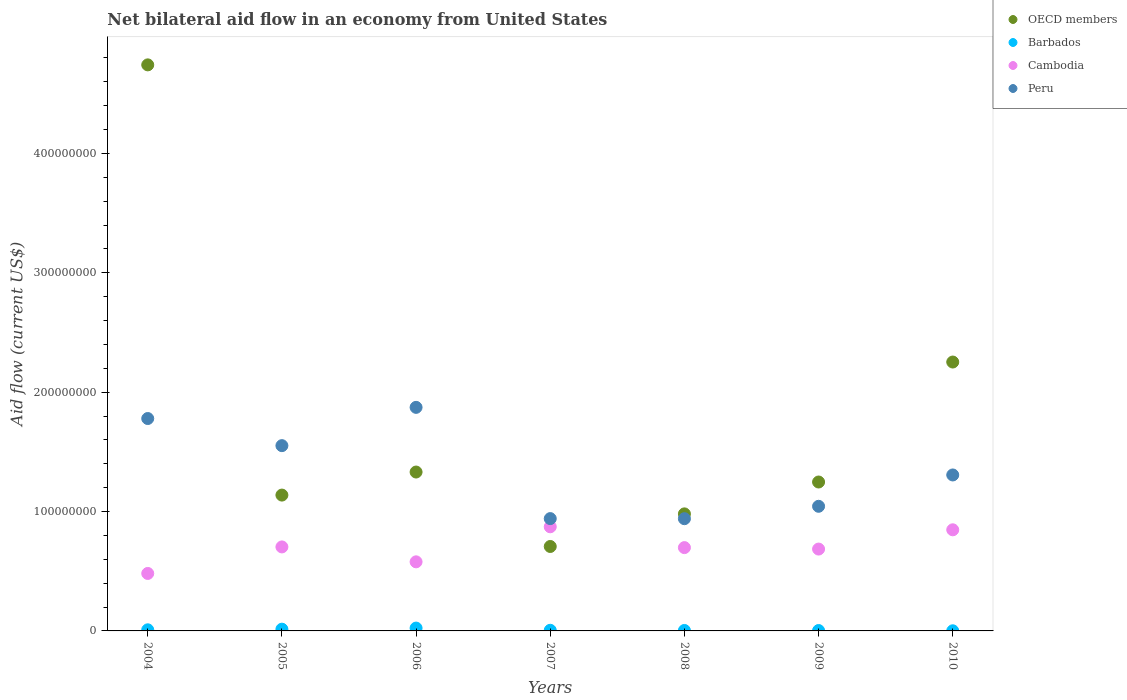What is the net bilateral aid flow in Peru in 2008?
Offer a very short reply. 9.40e+07. Across all years, what is the maximum net bilateral aid flow in OECD members?
Your answer should be compact. 4.74e+08. Across all years, what is the minimum net bilateral aid flow in Cambodia?
Give a very brief answer. 4.81e+07. What is the total net bilateral aid flow in Barbados in the graph?
Give a very brief answer. 6.13e+06. What is the difference between the net bilateral aid flow in OECD members in 2006 and that in 2007?
Keep it short and to the point. 6.24e+07. What is the difference between the net bilateral aid flow in Cambodia in 2006 and the net bilateral aid flow in OECD members in 2007?
Give a very brief answer. -1.29e+07. What is the average net bilateral aid flow in Peru per year?
Provide a short and direct response. 1.35e+08. In the year 2009, what is the difference between the net bilateral aid flow in Barbados and net bilateral aid flow in OECD members?
Give a very brief answer. -1.24e+08. What is the ratio of the net bilateral aid flow in Peru in 2007 to that in 2009?
Keep it short and to the point. 0.9. What is the difference between the highest and the second highest net bilateral aid flow in OECD members?
Offer a terse response. 2.49e+08. What is the difference between the highest and the lowest net bilateral aid flow in OECD members?
Keep it short and to the point. 4.03e+08. In how many years, is the net bilateral aid flow in Peru greater than the average net bilateral aid flow in Peru taken over all years?
Your response must be concise. 3. Is the net bilateral aid flow in Cambodia strictly greater than the net bilateral aid flow in Barbados over the years?
Your answer should be compact. Yes. How many dotlines are there?
Your answer should be compact. 4. What is the difference between two consecutive major ticks on the Y-axis?
Your response must be concise. 1.00e+08. Are the values on the major ticks of Y-axis written in scientific E-notation?
Offer a terse response. No. Does the graph contain any zero values?
Your answer should be very brief. No. Where does the legend appear in the graph?
Your answer should be compact. Top right. What is the title of the graph?
Make the answer very short. Net bilateral aid flow in an economy from United States. Does "Kenya" appear as one of the legend labels in the graph?
Ensure brevity in your answer.  No. What is the label or title of the X-axis?
Offer a terse response. Years. What is the Aid flow (current US$) in OECD members in 2004?
Provide a succinct answer. 4.74e+08. What is the Aid flow (current US$) in Barbados in 2004?
Ensure brevity in your answer.  9.30e+05. What is the Aid flow (current US$) of Cambodia in 2004?
Give a very brief answer. 4.81e+07. What is the Aid flow (current US$) in Peru in 2004?
Give a very brief answer. 1.78e+08. What is the Aid flow (current US$) in OECD members in 2005?
Your answer should be very brief. 1.14e+08. What is the Aid flow (current US$) in Barbados in 2005?
Your answer should be very brief. 1.46e+06. What is the Aid flow (current US$) of Cambodia in 2005?
Offer a very short reply. 7.04e+07. What is the Aid flow (current US$) of Peru in 2005?
Ensure brevity in your answer.  1.55e+08. What is the Aid flow (current US$) in OECD members in 2006?
Offer a terse response. 1.33e+08. What is the Aid flow (current US$) in Barbados in 2006?
Offer a very short reply. 2.38e+06. What is the Aid flow (current US$) of Cambodia in 2006?
Give a very brief answer. 5.79e+07. What is the Aid flow (current US$) in Peru in 2006?
Make the answer very short. 1.87e+08. What is the Aid flow (current US$) in OECD members in 2007?
Ensure brevity in your answer.  7.07e+07. What is the Aid flow (current US$) in Barbados in 2007?
Provide a short and direct response. 5.30e+05. What is the Aid flow (current US$) of Cambodia in 2007?
Offer a very short reply. 8.72e+07. What is the Aid flow (current US$) in Peru in 2007?
Keep it short and to the point. 9.41e+07. What is the Aid flow (current US$) in OECD members in 2008?
Your answer should be compact. 9.80e+07. What is the Aid flow (current US$) in Cambodia in 2008?
Provide a succinct answer. 6.98e+07. What is the Aid flow (current US$) of Peru in 2008?
Keep it short and to the point. 9.40e+07. What is the Aid flow (current US$) in OECD members in 2009?
Make the answer very short. 1.25e+08. What is the Aid flow (current US$) of Cambodia in 2009?
Your answer should be very brief. 6.86e+07. What is the Aid flow (current US$) in Peru in 2009?
Your answer should be compact. 1.04e+08. What is the Aid flow (current US$) in OECD members in 2010?
Provide a short and direct response. 2.25e+08. What is the Aid flow (current US$) in Barbados in 2010?
Provide a succinct answer. 1.10e+05. What is the Aid flow (current US$) of Cambodia in 2010?
Your answer should be compact. 8.47e+07. What is the Aid flow (current US$) of Peru in 2010?
Your answer should be very brief. 1.31e+08. Across all years, what is the maximum Aid flow (current US$) in OECD members?
Your response must be concise. 4.74e+08. Across all years, what is the maximum Aid flow (current US$) in Barbados?
Keep it short and to the point. 2.38e+06. Across all years, what is the maximum Aid flow (current US$) in Cambodia?
Offer a very short reply. 8.72e+07. Across all years, what is the maximum Aid flow (current US$) in Peru?
Your answer should be very brief. 1.87e+08. Across all years, what is the minimum Aid flow (current US$) in OECD members?
Your response must be concise. 7.07e+07. Across all years, what is the minimum Aid flow (current US$) of Cambodia?
Your answer should be very brief. 4.81e+07. Across all years, what is the minimum Aid flow (current US$) in Peru?
Give a very brief answer. 9.40e+07. What is the total Aid flow (current US$) of OECD members in the graph?
Your answer should be very brief. 1.24e+09. What is the total Aid flow (current US$) in Barbados in the graph?
Provide a short and direct response. 6.13e+06. What is the total Aid flow (current US$) in Cambodia in the graph?
Your answer should be compact. 4.87e+08. What is the total Aid flow (current US$) of Peru in the graph?
Provide a succinct answer. 9.43e+08. What is the difference between the Aid flow (current US$) of OECD members in 2004 and that in 2005?
Provide a succinct answer. 3.60e+08. What is the difference between the Aid flow (current US$) in Barbados in 2004 and that in 2005?
Give a very brief answer. -5.30e+05. What is the difference between the Aid flow (current US$) in Cambodia in 2004 and that in 2005?
Provide a short and direct response. -2.22e+07. What is the difference between the Aid flow (current US$) of Peru in 2004 and that in 2005?
Your response must be concise. 2.27e+07. What is the difference between the Aid flow (current US$) of OECD members in 2004 and that in 2006?
Offer a very short reply. 3.41e+08. What is the difference between the Aid flow (current US$) in Barbados in 2004 and that in 2006?
Your answer should be compact. -1.45e+06. What is the difference between the Aid flow (current US$) in Cambodia in 2004 and that in 2006?
Your answer should be compact. -9.73e+06. What is the difference between the Aid flow (current US$) of Peru in 2004 and that in 2006?
Your answer should be compact. -9.35e+06. What is the difference between the Aid flow (current US$) of OECD members in 2004 and that in 2007?
Your answer should be compact. 4.03e+08. What is the difference between the Aid flow (current US$) in Barbados in 2004 and that in 2007?
Your answer should be compact. 4.00e+05. What is the difference between the Aid flow (current US$) in Cambodia in 2004 and that in 2007?
Ensure brevity in your answer.  -3.91e+07. What is the difference between the Aid flow (current US$) in Peru in 2004 and that in 2007?
Offer a terse response. 8.38e+07. What is the difference between the Aid flow (current US$) of OECD members in 2004 and that in 2008?
Offer a terse response. 3.76e+08. What is the difference between the Aid flow (current US$) in Barbados in 2004 and that in 2008?
Make the answer very short. 5.40e+05. What is the difference between the Aid flow (current US$) of Cambodia in 2004 and that in 2008?
Your answer should be very brief. -2.16e+07. What is the difference between the Aid flow (current US$) of Peru in 2004 and that in 2008?
Provide a short and direct response. 8.39e+07. What is the difference between the Aid flow (current US$) in OECD members in 2004 and that in 2009?
Keep it short and to the point. 3.49e+08. What is the difference between the Aid flow (current US$) in Cambodia in 2004 and that in 2009?
Keep it short and to the point. -2.04e+07. What is the difference between the Aid flow (current US$) in Peru in 2004 and that in 2009?
Your response must be concise. 7.35e+07. What is the difference between the Aid flow (current US$) in OECD members in 2004 and that in 2010?
Give a very brief answer. 2.49e+08. What is the difference between the Aid flow (current US$) in Barbados in 2004 and that in 2010?
Offer a very short reply. 8.20e+05. What is the difference between the Aid flow (current US$) in Cambodia in 2004 and that in 2010?
Make the answer very short. -3.66e+07. What is the difference between the Aid flow (current US$) in Peru in 2004 and that in 2010?
Offer a terse response. 4.73e+07. What is the difference between the Aid flow (current US$) in OECD members in 2005 and that in 2006?
Your response must be concise. -1.93e+07. What is the difference between the Aid flow (current US$) of Barbados in 2005 and that in 2006?
Your answer should be compact. -9.20e+05. What is the difference between the Aid flow (current US$) of Cambodia in 2005 and that in 2006?
Give a very brief answer. 1.25e+07. What is the difference between the Aid flow (current US$) of Peru in 2005 and that in 2006?
Ensure brevity in your answer.  -3.21e+07. What is the difference between the Aid flow (current US$) in OECD members in 2005 and that in 2007?
Ensure brevity in your answer.  4.30e+07. What is the difference between the Aid flow (current US$) in Barbados in 2005 and that in 2007?
Offer a terse response. 9.30e+05. What is the difference between the Aid flow (current US$) of Cambodia in 2005 and that in 2007?
Your answer should be very brief. -1.69e+07. What is the difference between the Aid flow (current US$) of Peru in 2005 and that in 2007?
Provide a short and direct response. 6.11e+07. What is the difference between the Aid flow (current US$) in OECD members in 2005 and that in 2008?
Ensure brevity in your answer.  1.57e+07. What is the difference between the Aid flow (current US$) of Barbados in 2005 and that in 2008?
Your response must be concise. 1.07e+06. What is the difference between the Aid flow (current US$) of Cambodia in 2005 and that in 2008?
Your answer should be very brief. 5.80e+05. What is the difference between the Aid flow (current US$) in Peru in 2005 and that in 2008?
Keep it short and to the point. 6.12e+07. What is the difference between the Aid flow (current US$) of OECD members in 2005 and that in 2009?
Ensure brevity in your answer.  -1.10e+07. What is the difference between the Aid flow (current US$) in Barbados in 2005 and that in 2009?
Ensure brevity in your answer.  1.13e+06. What is the difference between the Aid flow (current US$) of Cambodia in 2005 and that in 2009?
Offer a terse response. 1.80e+06. What is the difference between the Aid flow (current US$) in Peru in 2005 and that in 2009?
Ensure brevity in your answer.  5.08e+07. What is the difference between the Aid flow (current US$) of OECD members in 2005 and that in 2010?
Make the answer very short. -1.11e+08. What is the difference between the Aid flow (current US$) in Barbados in 2005 and that in 2010?
Ensure brevity in your answer.  1.35e+06. What is the difference between the Aid flow (current US$) in Cambodia in 2005 and that in 2010?
Your answer should be very brief. -1.43e+07. What is the difference between the Aid flow (current US$) in Peru in 2005 and that in 2010?
Provide a short and direct response. 2.46e+07. What is the difference between the Aid flow (current US$) in OECD members in 2006 and that in 2007?
Provide a short and direct response. 6.24e+07. What is the difference between the Aid flow (current US$) in Barbados in 2006 and that in 2007?
Provide a short and direct response. 1.85e+06. What is the difference between the Aid flow (current US$) of Cambodia in 2006 and that in 2007?
Offer a very short reply. -2.94e+07. What is the difference between the Aid flow (current US$) of Peru in 2006 and that in 2007?
Keep it short and to the point. 9.32e+07. What is the difference between the Aid flow (current US$) of OECD members in 2006 and that in 2008?
Make the answer very short. 3.50e+07. What is the difference between the Aid flow (current US$) of Barbados in 2006 and that in 2008?
Make the answer very short. 1.99e+06. What is the difference between the Aid flow (current US$) of Cambodia in 2006 and that in 2008?
Make the answer very short. -1.19e+07. What is the difference between the Aid flow (current US$) of Peru in 2006 and that in 2008?
Make the answer very short. 9.33e+07. What is the difference between the Aid flow (current US$) in OECD members in 2006 and that in 2009?
Offer a terse response. 8.36e+06. What is the difference between the Aid flow (current US$) in Barbados in 2006 and that in 2009?
Keep it short and to the point. 2.05e+06. What is the difference between the Aid flow (current US$) of Cambodia in 2006 and that in 2009?
Give a very brief answer. -1.07e+07. What is the difference between the Aid flow (current US$) of Peru in 2006 and that in 2009?
Make the answer very short. 8.29e+07. What is the difference between the Aid flow (current US$) in OECD members in 2006 and that in 2010?
Give a very brief answer. -9.21e+07. What is the difference between the Aid flow (current US$) of Barbados in 2006 and that in 2010?
Offer a very short reply. 2.27e+06. What is the difference between the Aid flow (current US$) of Cambodia in 2006 and that in 2010?
Give a very brief answer. -2.68e+07. What is the difference between the Aid flow (current US$) of Peru in 2006 and that in 2010?
Your answer should be compact. 5.66e+07. What is the difference between the Aid flow (current US$) of OECD members in 2007 and that in 2008?
Provide a succinct answer. -2.73e+07. What is the difference between the Aid flow (current US$) in Cambodia in 2007 and that in 2008?
Your answer should be compact. 1.74e+07. What is the difference between the Aid flow (current US$) of Peru in 2007 and that in 2008?
Provide a succinct answer. 8.00e+04. What is the difference between the Aid flow (current US$) of OECD members in 2007 and that in 2009?
Provide a succinct answer. -5.40e+07. What is the difference between the Aid flow (current US$) in Barbados in 2007 and that in 2009?
Offer a very short reply. 2.00e+05. What is the difference between the Aid flow (current US$) of Cambodia in 2007 and that in 2009?
Offer a terse response. 1.87e+07. What is the difference between the Aid flow (current US$) in Peru in 2007 and that in 2009?
Your answer should be compact. -1.03e+07. What is the difference between the Aid flow (current US$) of OECD members in 2007 and that in 2010?
Your answer should be very brief. -1.54e+08. What is the difference between the Aid flow (current US$) in Cambodia in 2007 and that in 2010?
Your answer should be compact. 2.52e+06. What is the difference between the Aid flow (current US$) in Peru in 2007 and that in 2010?
Your response must be concise. -3.66e+07. What is the difference between the Aid flow (current US$) of OECD members in 2008 and that in 2009?
Your response must be concise. -2.67e+07. What is the difference between the Aid flow (current US$) in Barbados in 2008 and that in 2009?
Give a very brief answer. 6.00e+04. What is the difference between the Aid flow (current US$) of Cambodia in 2008 and that in 2009?
Your response must be concise. 1.22e+06. What is the difference between the Aid flow (current US$) in Peru in 2008 and that in 2009?
Make the answer very short. -1.04e+07. What is the difference between the Aid flow (current US$) of OECD members in 2008 and that in 2010?
Ensure brevity in your answer.  -1.27e+08. What is the difference between the Aid flow (current US$) in Barbados in 2008 and that in 2010?
Ensure brevity in your answer.  2.80e+05. What is the difference between the Aid flow (current US$) in Cambodia in 2008 and that in 2010?
Your response must be concise. -1.49e+07. What is the difference between the Aid flow (current US$) in Peru in 2008 and that in 2010?
Give a very brief answer. -3.66e+07. What is the difference between the Aid flow (current US$) of OECD members in 2009 and that in 2010?
Make the answer very short. -1.00e+08. What is the difference between the Aid flow (current US$) of Barbados in 2009 and that in 2010?
Make the answer very short. 2.20e+05. What is the difference between the Aid flow (current US$) of Cambodia in 2009 and that in 2010?
Provide a succinct answer. -1.61e+07. What is the difference between the Aid flow (current US$) in Peru in 2009 and that in 2010?
Provide a succinct answer. -2.62e+07. What is the difference between the Aid flow (current US$) of OECD members in 2004 and the Aid flow (current US$) of Barbados in 2005?
Your response must be concise. 4.73e+08. What is the difference between the Aid flow (current US$) in OECD members in 2004 and the Aid flow (current US$) in Cambodia in 2005?
Give a very brief answer. 4.04e+08. What is the difference between the Aid flow (current US$) of OECD members in 2004 and the Aid flow (current US$) of Peru in 2005?
Give a very brief answer. 3.19e+08. What is the difference between the Aid flow (current US$) of Barbados in 2004 and the Aid flow (current US$) of Cambodia in 2005?
Make the answer very short. -6.94e+07. What is the difference between the Aid flow (current US$) of Barbados in 2004 and the Aid flow (current US$) of Peru in 2005?
Make the answer very short. -1.54e+08. What is the difference between the Aid flow (current US$) of Cambodia in 2004 and the Aid flow (current US$) of Peru in 2005?
Offer a very short reply. -1.07e+08. What is the difference between the Aid flow (current US$) in OECD members in 2004 and the Aid flow (current US$) in Barbados in 2006?
Offer a terse response. 4.72e+08. What is the difference between the Aid flow (current US$) in OECD members in 2004 and the Aid flow (current US$) in Cambodia in 2006?
Keep it short and to the point. 4.16e+08. What is the difference between the Aid flow (current US$) in OECD members in 2004 and the Aid flow (current US$) in Peru in 2006?
Provide a succinct answer. 2.87e+08. What is the difference between the Aid flow (current US$) in Barbados in 2004 and the Aid flow (current US$) in Cambodia in 2006?
Your response must be concise. -5.69e+07. What is the difference between the Aid flow (current US$) of Barbados in 2004 and the Aid flow (current US$) of Peru in 2006?
Your answer should be very brief. -1.86e+08. What is the difference between the Aid flow (current US$) of Cambodia in 2004 and the Aid flow (current US$) of Peru in 2006?
Offer a very short reply. -1.39e+08. What is the difference between the Aid flow (current US$) of OECD members in 2004 and the Aid flow (current US$) of Barbados in 2007?
Offer a terse response. 4.74e+08. What is the difference between the Aid flow (current US$) in OECD members in 2004 and the Aid flow (current US$) in Cambodia in 2007?
Offer a terse response. 3.87e+08. What is the difference between the Aid flow (current US$) in OECD members in 2004 and the Aid flow (current US$) in Peru in 2007?
Ensure brevity in your answer.  3.80e+08. What is the difference between the Aid flow (current US$) of Barbados in 2004 and the Aid flow (current US$) of Cambodia in 2007?
Your answer should be compact. -8.63e+07. What is the difference between the Aid flow (current US$) in Barbados in 2004 and the Aid flow (current US$) in Peru in 2007?
Offer a terse response. -9.32e+07. What is the difference between the Aid flow (current US$) of Cambodia in 2004 and the Aid flow (current US$) of Peru in 2007?
Give a very brief answer. -4.59e+07. What is the difference between the Aid flow (current US$) of OECD members in 2004 and the Aid flow (current US$) of Barbados in 2008?
Provide a short and direct response. 4.74e+08. What is the difference between the Aid flow (current US$) of OECD members in 2004 and the Aid flow (current US$) of Cambodia in 2008?
Provide a short and direct response. 4.04e+08. What is the difference between the Aid flow (current US$) of OECD members in 2004 and the Aid flow (current US$) of Peru in 2008?
Provide a succinct answer. 3.80e+08. What is the difference between the Aid flow (current US$) in Barbados in 2004 and the Aid flow (current US$) in Cambodia in 2008?
Keep it short and to the point. -6.88e+07. What is the difference between the Aid flow (current US$) in Barbados in 2004 and the Aid flow (current US$) in Peru in 2008?
Your answer should be compact. -9.31e+07. What is the difference between the Aid flow (current US$) in Cambodia in 2004 and the Aid flow (current US$) in Peru in 2008?
Your answer should be compact. -4.59e+07. What is the difference between the Aid flow (current US$) in OECD members in 2004 and the Aid flow (current US$) in Barbados in 2009?
Offer a terse response. 4.74e+08. What is the difference between the Aid flow (current US$) in OECD members in 2004 and the Aid flow (current US$) in Cambodia in 2009?
Provide a succinct answer. 4.06e+08. What is the difference between the Aid flow (current US$) in OECD members in 2004 and the Aid flow (current US$) in Peru in 2009?
Keep it short and to the point. 3.70e+08. What is the difference between the Aid flow (current US$) in Barbados in 2004 and the Aid flow (current US$) in Cambodia in 2009?
Keep it short and to the point. -6.76e+07. What is the difference between the Aid flow (current US$) in Barbados in 2004 and the Aid flow (current US$) in Peru in 2009?
Offer a terse response. -1.03e+08. What is the difference between the Aid flow (current US$) in Cambodia in 2004 and the Aid flow (current US$) in Peru in 2009?
Provide a succinct answer. -5.62e+07. What is the difference between the Aid flow (current US$) of OECD members in 2004 and the Aid flow (current US$) of Barbados in 2010?
Ensure brevity in your answer.  4.74e+08. What is the difference between the Aid flow (current US$) in OECD members in 2004 and the Aid flow (current US$) in Cambodia in 2010?
Give a very brief answer. 3.89e+08. What is the difference between the Aid flow (current US$) of OECD members in 2004 and the Aid flow (current US$) of Peru in 2010?
Provide a short and direct response. 3.44e+08. What is the difference between the Aid flow (current US$) of Barbados in 2004 and the Aid flow (current US$) of Cambodia in 2010?
Your response must be concise. -8.38e+07. What is the difference between the Aid flow (current US$) of Barbados in 2004 and the Aid flow (current US$) of Peru in 2010?
Give a very brief answer. -1.30e+08. What is the difference between the Aid flow (current US$) in Cambodia in 2004 and the Aid flow (current US$) in Peru in 2010?
Keep it short and to the point. -8.25e+07. What is the difference between the Aid flow (current US$) in OECD members in 2005 and the Aid flow (current US$) in Barbados in 2006?
Ensure brevity in your answer.  1.11e+08. What is the difference between the Aid flow (current US$) of OECD members in 2005 and the Aid flow (current US$) of Cambodia in 2006?
Offer a very short reply. 5.59e+07. What is the difference between the Aid flow (current US$) of OECD members in 2005 and the Aid flow (current US$) of Peru in 2006?
Give a very brief answer. -7.35e+07. What is the difference between the Aid flow (current US$) in Barbados in 2005 and the Aid flow (current US$) in Cambodia in 2006?
Provide a succinct answer. -5.64e+07. What is the difference between the Aid flow (current US$) in Barbados in 2005 and the Aid flow (current US$) in Peru in 2006?
Your answer should be very brief. -1.86e+08. What is the difference between the Aid flow (current US$) in Cambodia in 2005 and the Aid flow (current US$) in Peru in 2006?
Ensure brevity in your answer.  -1.17e+08. What is the difference between the Aid flow (current US$) of OECD members in 2005 and the Aid flow (current US$) of Barbados in 2007?
Your answer should be very brief. 1.13e+08. What is the difference between the Aid flow (current US$) of OECD members in 2005 and the Aid flow (current US$) of Cambodia in 2007?
Provide a succinct answer. 2.66e+07. What is the difference between the Aid flow (current US$) in OECD members in 2005 and the Aid flow (current US$) in Peru in 2007?
Your response must be concise. 1.97e+07. What is the difference between the Aid flow (current US$) of Barbados in 2005 and the Aid flow (current US$) of Cambodia in 2007?
Provide a succinct answer. -8.58e+07. What is the difference between the Aid flow (current US$) of Barbados in 2005 and the Aid flow (current US$) of Peru in 2007?
Your answer should be compact. -9.26e+07. What is the difference between the Aid flow (current US$) in Cambodia in 2005 and the Aid flow (current US$) in Peru in 2007?
Your response must be concise. -2.37e+07. What is the difference between the Aid flow (current US$) of OECD members in 2005 and the Aid flow (current US$) of Barbados in 2008?
Give a very brief answer. 1.13e+08. What is the difference between the Aid flow (current US$) in OECD members in 2005 and the Aid flow (current US$) in Cambodia in 2008?
Provide a succinct answer. 4.40e+07. What is the difference between the Aid flow (current US$) in OECD members in 2005 and the Aid flow (current US$) in Peru in 2008?
Offer a terse response. 1.98e+07. What is the difference between the Aid flow (current US$) in Barbados in 2005 and the Aid flow (current US$) in Cambodia in 2008?
Provide a short and direct response. -6.83e+07. What is the difference between the Aid flow (current US$) in Barbados in 2005 and the Aid flow (current US$) in Peru in 2008?
Your answer should be compact. -9.25e+07. What is the difference between the Aid flow (current US$) in Cambodia in 2005 and the Aid flow (current US$) in Peru in 2008?
Keep it short and to the point. -2.36e+07. What is the difference between the Aid flow (current US$) of OECD members in 2005 and the Aid flow (current US$) of Barbados in 2009?
Your response must be concise. 1.13e+08. What is the difference between the Aid flow (current US$) of OECD members in 2005 and the Aid flow (current US$) of Cambodia in 2009?
Ensure brevity in your answer.  4.52e+07. What is the difference between the Aid flow (current US$) in OECD members in 2005 and the Aid flow (current US$) in Peru in 2009?
Give a very brief answer. 9.39e+06. What is the difference between the Aid flow (current US$) in Barbados in 2005 and the Aid flow (current US$) in Cambodia in 2009?
Offer a terse response. -6.71e+07. What is the difference between the Aid flow (current US$) in Barbados in 2005 and the Aid flow (current US$) in Peru in 2009?
Your answer should be compact. -1.03e+08. What is the difference between the Aid flow (current US$) of Cambodia in 2005 and the Aid flow (current US$) of Peru in 2009?
Keep it short and to the point. -3.40e+07. What is the difference between the Aid flow (current US$) in OECD members in 2005 and the Aid flow (current US$) in Barbados in 2010?
Your response must be concise. 1.14e+08. What is the difference between the Aid flow (current US$) of OECD members in 2005 and the Aid flow (current US$) of Cambodia in 2010?
Provide a short and direct response. 2.91e+07. What is the difference between the Aid flow (current US$) in OECD members in 2005 and the Aid flow (current US$) in Peru in 2010?
Keep it short and to the point. -1.69e+07. What is the difference between the Aid flow (current US$) of Barbados in 2005 and the Aid flow (current US$) of Cambodia in 2010?
Make the answer very short. -8.32e+07. What is the difference between the Aid flow (current US$) in Barbados in 2005 and the Aid flow (current US$) in Peru in 2010?
Offer a terse response. -1.29e+08. What is the difference between the Aid flow (current US$) of Cambodia in 2005 and the Aid flow (current US$) of Peru in 2010?
Your answer should be very brief. -6.03e+07. What is the difference between the Aid flow (current US$) of OECD members in 2006 and the Aid flow (current US$) of Barbados in 2007?
Offer a very short reply. 1.33e+08. What is the difference between the Aid flow (current US$) in OECD members in 2006 and the Aid flow (current US$) in Cambodia in 2007?
Ensure brevity in your answer.  4.59e+07. What is the difference between the Aid flow (current US$) of OECD members in 2006 and the Aid flow (current US$) of Peru in 2007?
Your response must be concise. 3.90e+07. What is the difference between the Aid flow (current US$) in Barbados in 2006 and the Aid flow (current US$) in Cambodia in 2007?
Ensure brevity in your answer.  -8.48e+07. What is the difference between the Aid flow (current US$) of Barbados in 2006 and the Aid flow (current US$) of Peru in 2007?
Keep it short and to the point. -9.17e+07. What is the difference between the Aid flow (current US$) in Cambodia in 2006 and the Aid flow (current US$) in Peru in 2007?
Provide a short and direct response. -3.62e+07. What is the difference between the Aid flow (current US$) in OECD members in 2006 and the Aid flow (current US$) in Barbados in 2008?
Your answer should be very brief. 1.33e+08. What is the difference between the Aid flow (current US$) of OECD members in 2006 and the Aid flow (current US$) of Cambodia in 2008?
Offer a terse response. 6.33e+07. What is the difference between the Aid flow (current US$) of OECD members in 2006 and the Aid flow (current US$) of Peru in 2008?
Keep it short and to the point. 3.91e+07. What is the difference between the Aid flow (current US$) in Barbados in 2006 and the Aid flow (current US$) in Cambodia in 2008?
Offer a terse response. -6.74e+07. What is the difference between the Aid flow (current US$) of Barbados in 2006 and the Aid flow (current US$) of Peru in 2008?
Offer a terse response. -9.16e+07. What is the difference between the Aid flow (current US$) of Cambodia in 2006 and the Aid flow (current US$) of Peru in 2008?
Your response must be concise. -3.61e+07. What is the difference between the Aid flow (current US$) in OECD members in 2006 and the Aid flow (current US$) in Barbados in 2009?
Offer a terse response. 1.33e+08. What is the difference between the Aid flow (current US$) of OECD members in 2006 and the Aid flow (current US$) of Cambodia in 2009?
Make the answer very short. 6.45e+07. What is the difference between the Aid flow (current US$) of OECD members in 2006 and the Aid flow (current US$) of Peru in 2009?
Make the answer very short. 2.87e+07. What is the difference between the Aid flow (current US$) in Barbados in 2006 and the Aid flow (current US$) in Cambodia in 2009?
Provide a short and direct response. -6.62e+07. What is the difference between the Aid flow (current US$) of Barbados in 2006 and the Aid flow (current US$) of Peru in 2009?
Your answer should be very brief. -1.02e+08. What is the difference between the Aid flow (current US$) in Cambodia in 2006 and the Aid flow (current US$) in Peru in 2009?
Keep it short and to the point. -4.65e+07. What is the difference between the Aid flow (current US$) in OECD members in 2006 and the Aid flow (current US$) in Barbados in 2010?
Provide a succinct answer. 1.33e+08. What is the difference between the Aid flow (current US$) in OECD members in 2006 and the Aid flow (current US$) in Cambodia in 2010?
Ensure brevity in your answer.  4.84e+07. What is the difference between the Aid flow (current US$) of OECD members in 2006 and the Aid flow (current US$) of Peru in 2010?
Your answer should be very brief. 2.45e+06. What is the difference between the Aid flow (current US$) of Barbados in 2006 and the Aid flow (current US$) of Cambodia in 2010?
Make the answer very short. -8.23e+07. What is the difference between the Aid flow (current US$) of Barbados in 2006 and the Aid flow (current US$) of Peru in 2010?
Provide a succinct answer. -1.28e+08. What is the difference between the Aid flow (current US$) in Cambodia in 2006 and the Aid flow (current US$) in Peru in 2010?
Provide a short and direct response. -7.28e+07. What is the difference between the Aid flow (current US$) of OECD members in 2007 and the Aid flow (current US$) of Barbados in 2008?
Offer a very short reply. 7.03e+07. What is the difference between the Aid flow (current US$) in OECD members in 2007 and the Aid flow (current US$) in Cambodia in 2008?
Give a very brief answer. 9.50e+05. What is the difference between the Aid flow (current US$) of OECD members in 2007 and the Aid flow (current US$) of Peru in 2008?
Offer a very short reply. -2.33e+07. What is the difference between the Aid flow (current US$) of Barbados in 2007 and the Aid flow (current US$) of Cambodia in 2008?
Your answer should be very brief. -6.92e+07. What is the difference between the Aid flow (current US$) in Barbados in 2007 and the Aid flow (current US$) in Peru in 2008?
Give a very brief answer. -9.35e+07. What is the difference between the Aid flow (current US$) of Cambodia in 2007 and the Aid flow (current US$) of Peru in 2008?
Keep it short and to the point. -6.78e+06. What is the difference between the Aid flow (current US$) in OECD members in 2007 and the Aid flow (current US$) in Barbados in 2009?
Offer a terse response. 7.04e+07. What is the difference between the Aid flow (current US$) of OECD members in 2007 and the Aid flow (current US$) of Cambodia in 2009?
Provide a short and direct response. 2.17e+06. What is the difference between the Aid flow (current US$) of OECD members in 2007 and the Aid flow (current US$) of Peru in 2009?
Your answer should be very brief. -3.37e+07. What is the difference between the Aid flow (current US$) of Barbados in 2007 and the Aid flow (current US$) of Cambodia in 2009?
Give a very brief answer. -6.80e+07. What is the difference between the Aid flow (current US$) of Barbados in 2007 and the Aid flow (current US$) of Peru in 2009?
Your answer should be very brief. -1.04e+08. What is the difference between the Aid flow (current US$) in Cambodia in 2007 and the Aid flow (current US$) in Peru in 2009?
Offer a terse response. -1.72e+07. What is the difference between the Aid flow (current US$) of OECD members in 2007 and the Aid flow (current US$) of Barbados in 2010?
Offer a very short reply. 7.06e+07. What is the difference between the Aid flow (current US$) in OECD members in 2007 and the Aid flow (current US$) in Cambodia in 2010?
Your answer should be very brief. -1.40e+07. What is the difference between the Aid flow (current US$) of OECD members in 2007 and the Aid flow (current US$) of Peru in 2010?
Ensure brevity in your answer.  -5.99e+07. What is the difference between the Aid flow (current US$) in Barbados in 2007 and the Aid flow (current US$) in Cambodia in 2010?
Offer a very short reply. -8.42e+07. What is the difference between the Aid flow (current US$) of Barbados in 2007 and the Aid flow (current US$) of Peru in 2010?
Offer a very short reply. -1.30e+08. What is the difference between the Aid flow (current US$) in Cambodia in 2007 and the Aid flow (current US$) in Peru in 2010?
Provide a succinct answer. -4.34e+07. What is the difference between the Aid flow (current US$) of OECD members in 2008 and the Aid flow (current US$) of Barbados in 2009?
Offer a terse response. 9.77e+07. What is the difference between the Aid flow (current US$) in OECD members in 2008 and the Aid flow (current US$) in Cambodia in 2009?
Your response must be concise. 2.95e+07. What is the difference between the Aid flow (current US$) in OECD members in 2008 and the Aid flow (current US$) in Peru in 2009?
Give a very brief answer. -6.35e+06. What is the difference between the Aid flow (current US$) in Barbados in 2008 and the Aid flow (current US$) in Cambodia in 2009?
Provide a short and direct response. -6.82e+07. What is the difference between the Aid flow (current US$) of Barbados in 2008 and the Aid flow (current US$) of Peru in 2009?
Ensure brevity in your answer.  -1.04e+08. What is the difference between the Aid flow (current US$) in Cambodia in 2008 and the Aid flow (current US$) in Peru in 2009?
Offer a very short reply. -3.46e+07. What is the difference between the Aid flow (current US$) in OECD members in 2008 and the Aid flow (current US$) in Barbados in 2010?
Ensure brevity in your answer.  9.79e+07. What is the difference between the Aid flow (current US$) in OECD members in 2008 and the Aid flow (current US$) in Cambodia in 2010?
Ensure brevity in your answer.  1.33e+07. What is the difference between the Aid flow (current US$) in OECD members in 2008 and the Aid flow (current US$) in Peru in 2010?
Offer a terse response. -3.26e+07. What is the difference between the Aid flow (current US$) in Barbados in 2008 and the Aid flow (current US$) in Cambodia in 2010?
Your answer should be compact. -8.43e+07. What is the difference between the Aid flow (current US$) of Barbados in 2008 and the Aid flow (current US$) of Peru in 2010?
Ensure brevity in your answer.  -1.30e+08. What is the difference between the Aid flow (current US$) in Cambodia in 2008 and the Aid flow (current US$) in Peru in 2010?
Keep it short and to the point. -6.09e+07. What is the difference between the Aid flow (current US$) in OECD members in 2009 and the Aid flow (current US$) in Barbados in 2010?
Ensure brevity in your answer.  1.25e+08. What is the difference between the Aid flow (current US$) of OECD members in 2009 and the Aid flow (current US$) of Cambodia in 2010?
Give a very brief answer. 4.00e+07. What is the difference between the Aid flow (current US$) of OECD members in 2009 and the Aid flow (current US$) of Peru in 2010?
Offer a terse response. -5.91e+06. What is the difference between the Aid flow (current US$) of Barbados in 2009 and the Aid flow (current US$) of Cambodia in 2010?
Your response must be concise. -8.44e+07. What is the difference between the Aid flow (current US$) of Barbados in 2009 and the Aid flow (current US$) of Peru in 2010?
Keep it short and to the point. -1.30e+08. What is the difference between the Aid flow (current US$) in Cambodia in 2009 and the Aid flow (current US$) in Peru in 2010?
Provide a short and direct response. -6.21e+07. What is the average Aid flow (current US$) in OECD members per year?
Your answer should be very brief. 1.77e+08. What is the average Aid flow (current US$) in Barbados per year?
Your answer should be very brief. 8.76e+05. What is the average Aid flow (current US$) of Cambodia per year?
Provide a short and direct response. 6.95e+07. What is the average Aid flow (current US$) of Peru per year?
Give a very brief answer. 1.35e+08. In the year 2004, what is the difference between the Aid flow (current US$) of OECD members and Aid flow (current US$) of Barbados?
Offer a very short reply. 4.73e+08. In the year 2004, what is the difference between the Aid flow (current US$) of OECD members and Aid flow (current US$) of Cambodia?
Offer a very short reply. 4.26e+08. In the year 2004, what is the difference between the Aid flow (current US$) of OECD members and Aid flow (current US$) of Peru?
Make the answer very short. 2.96e+08. In the year 2004, what is the difference between the Aid flow (current US$) of Barbados and Aid flow (current US$) of Cambodia?
Your answer should be very brief. -4.72e+07. In the year 2004, what is the difference between the Aid flow (current US$) in Barbados and Aid flow (current US$) in Peru?
Provide a short and direct response. -1.77e+08. In the year 2004, what is the difference between the Aid flow (current US$) of Cambodia and Aid flow (current US$) of Peru?
Make the answer very short. -1.30e+08. In the year 2005, what is the difference between the Aid flow (current US$) of OECD members and Aid flow (current US$) of Barbados?
Provide a succinct answer. 1.12e+08. In the year 2005, what is the difference between the Aid flow (current US$) of OECD members and Aid flow (current US$) of Cambodia?
Your answer should be compact. 4.34e+07. In the year 2005, what is the difference between the Aid flow (current US$) of OECD members and Aid flow (current US$) of Peru?
Your response must be concise. -4.14e+07. In the year 2005, what is the difference between the Aid flow (current US$) in Barbados and Aid flow (current US$) in Cambodia?
Ensure brevity in your answer.  -6.89e+07. In the year 2005, what is the difference between the Aid flow (current US$) of Barbados and Aid flow (current US$) of Peru?
Give a very brief answer. -1.54e+08. In the year 2005, what is the difference between the Aid flow (current US$) of Cambodia and Aid flow (current US$) of Peru?
Give a very brief answer. -8.48e+07. In the year 2006, what is the difference between the Aid flow (current US$) in OECD members and Aid flow (current US$) in Barbados?
Your answer should be compact. 1.31e+08. In the year 2006, what is the difference between the Aid flow (current US$) in OECD members and Aid flow (current US$) in Cambodia?
Ensure brevity in your answer.  7.52e+07. In the year 2006, what is the difference between the Aid flow (current US$) in OECD members and Aid flow (current US$) in Peru?
Make the answer very short. -5.42e+07. In the year 2006, what is the difference between the Aid flow (current US$) in Barbados and Aid flow (current US$) in Cambodia?
Ensure brevity in your answer.  -5.55e+07. In the year 2006, what is the difference between the Aid flow (current US$) in Barbados and Aid flow (current US$) in Peru?
Your answer should be very brief. -1.85e+08. In the year 2006, what is the difference between the Aid flow (current US$) in Cambodia and Aid flow (current US$) in Peru?
Provide a short and direct response. -1.29e+08. In the year 2007, what is the difference between the Aid flow (current US$) of OECD members and Aid flow (current US$) of Barbados?
Your response must be concise. 7.02e+07. In the year 2007, what is the difference between the Aid flow (current US$) in OECD members and Aid flow (current US$) in Cambodia?
Your response must be concise. -1.65e+07. In the year 2007, what is the difference between the Aid flow (current US$) of OECD members and Aid flow (current US$) of Peru?
Make the answer very short. -2.34e+07. In the year 2007, what is the difference between the Aid flow (current US$) of Barbados and Aid flow (current US$) of Cambodia?
Your answer should be compact. -8.67e+07. In the year 2007, what is the difference between the Aid flow (current US$) of Barbados and Aid flow (current US$) of Peru?
Make the answer very short. -9.36e+07. In the year 2007, what is the difference between the Aid flow (current US$) in Cambodia and Aid flow (current US$) in Peru?
Your answer should be very brief. -6.86e+06. In the year 2008, what is the difference between the Aid flow (current US$) of OECD members and Aid flow (current US$) of Barbados?
Offer a very short reply. 9.76e+07. In the year 2008, what is the difference between the Aid flow (current US$) in OECD members and Aid flow (current US$) in Cambodia?
Offer a terse response. 2.83e+07. In the year 2008, what is the difference between the Aid flow (current US$) of OECD members and Aid flow (current US$) of Peru?
Provide a succinct answer. 4.04e+06. In the year 2008, what is the difference between the Aid flow (current US$) in Barbados and Aid flow (current US$) in Cambodia?
Ensure brevity in your answer.  -6.94e+07. In the year 2008, what is the difference between the Aid flow (current US$) in Barbados and Aid flow (current US$) in Peru?
Make the answer very short. -9.36e+07. In the year 2008, what is the difference between the Aid flow (current US$) in Cambodia and Aid flow (current US$) in Peru?
Your response must be concise. -2.42e+07. In the year 2009, what is the difference between the Aid flow (current US$) in OECD members and Aid flow (current US$) in Barbados?
Offer a terse response. 1.24e+08. In the year 2009, what is the difference between the Aid flow (current US$) of OECD members and Aid flow (current US$) of Cambodia?
Provide a short and direct response. 5.62e+07. In the year 2009, what is the difference between the Aid flow (current US$) in OECD members and Aid flow (current US$) in Peru?
Keep it short and to the point. 2.03e+07. In the year 2009, what is the difference between the Aid flow (current US$) of Barbados and Aid flow (current US$) of Cambodia?
Make the answer very short. -6.82e+07. In the year 2009, what is the difference between the Aid flow (current US$) of Barbados and Aid flow (current US$) of Peru?
Provide a short and direct response. -1.04e+08. In the year 2009, what is the difference between the Aid flow (current US$) of Cambodia and Aid flow (current US$) of Peru?
Provide a succinct answer. -3.58e+07. In the year 2010, what is the difference between the Aid flow (current US$) in OECD members and Aid flow (current US$) in Barbados?
Your response must be concise. 2.25e+08. In the year 2010, what is the difference between the Aid flow (current US$) of OECD members and Aid flow (current US$) of Cambodia?
Your answer should be compact. 1.41e+08. In the year 2010, what is the difference between the Aid flow (current US$) in OECD members and Aid flow (current US$) in Peru?
Ensure brevity in your answer.  9.46e+07. In the year 2010, what is the difference between the Aid flow (current US$) in Barbados and Aid flow (current US$) in Cambodia?
Your answer should be compact. -8.46e+07. In the year 2010, what is the difference between the Aid flow (current US$) in Barbados and Aid flow (current US$) in Peru?
Keep it short and to the point. -1.31e+08. In the year 2010, what is the difference between the Aid flow (current US$) of Cambodia and Aid flow (current US$) of Peru?
Your response must be concise. -4.59e+07. What is the ratio of the Aid flow (current US$) in OECD members in 2004 to that in 2005?
Your response must be concise. 4.17. What is the ratio of the Aid flow (current US$) in Barbados in 2004 to that in 2005?
Your answer should be very brief. 0.64. What is the ratio of the Aid flow (current US$) in Cambodia in 2004 to that in 2005?
Your answer should be very brief. 0.68. What is the ratio of the Aid flow (current US$) in Peru in 2004 to that in 2005?
Ensure brevity in your answer.  1.15. What is the ratio of the Aid flow (current US$) in OECD members in 2004 to that in 2006?
Your answer should be compact. 3.56. What is the ratio of the Aid flow (current US$) of Barbados in 2004 to that in 2006?
Provide a short and direct response. 0.39. What is the ratio of the Aid flow (current US$) of Cambodia in 2004 to that in 2006?
Your response must be concise. 0.83. What is the ratio of the Aid flow (current US$) of Peru in 2004 to that in 2006?
Provide a short and direct response. 0.95. What is the ratio of the Aid flow (current US$) of OECD members in 2004 to that in 2007?
Keep it short and to the point. 6.7. What is the ratio of the Aid flow (current US$) of Barbados in 2004 to that in 2007?
Offer a terse response. 1.75. What is the ratio of the Aid flow (current US$) in Cambodia in 2004 to that in 2007?
Your answer should be compact. 0.55. What is the ratio of the Aid flow (current US$) of Peru in 2004 to that in 2007?
Your answer should be compact. 1.89. What is the ratio of the Aid flow (current US$) in OECD members in 2004 to that in 2008?
Your answer should be compact. 4.84. What is the ratio of the Aid flow (current US$) of Barbados in 2004 to that in 2008?
Provide a short and direct response. 2.38. What is the ratio of the Aid flow (current US$) of Cambodia in 2004 to that in 2008?
Keep it short and to the point. 0.69. What is the ratio of the Aid flow (current US$) in Peru in 2004 to that in 2008?
Offer a very short reply. 1.89. What is the ratio of the Aid flow (current US$) of OECD members in 2004 to that in 2009?
Offer a very short reply. 3.8. What is the ratio of the Aid flow (current US$) of Barbados in 2004 to that in 2009?
Ensure brevity in your answer.  2.82. What is the ratio of the Aid flow (current US$) of Cambodia in 2004 to that in 2009?
Offer a terse response. 0.7. What is the ratio of the Aid flow (current US$) in Peru in 2004 to that in 2009?
Give a very brief answer. 1.7. What is the ratio of the Aid flow (current US$) of OECD members in 2004 to that in 2010?
Your response must be concise. 2.11. What is the ratio of the Aid flow (current US$) of Barbados in 2004 to that in 2010?
Keep it short and to the point. 8.45. What is the ratio of the Aid flow (current US$) in Cambodia in 2004 to that in 2010?
Provide a succinct answer. 0.57. What is the ratio of the Aid flow (current US$) of Peru in 2004 to that in 2010?
Provide a succinct answer. 1.36. What is the ratio of the Aid flow (current US$) in OECD members in 2005 to that in 2006?
Offer a very short reply. 0.85. What is the ratio of the Aid flow (current US$) in Barbados in 2005 to that in 2006?
Offer a very short reply. 0.61. What is the ratio of the Aid flow (current US$) in Cambodia in 2005 to that in 2006?
Your response must be concise. 1.22. What is the ratio of the Aid flow (current US$) in Peru in 2005 to that in 2006?
Make the answer very short. 0.83. What is the ratio of the Aid flow (current US$) of OECD members in 2005 to that in 2007?
Make the answer very short. 1.61. What is the ratio of the Aid flow (current US$) in Barbados in 2005 to that in 2007?
Make the answer very short. 2.75. What is the ratio of the Aid flow (current US$) in Cambodia in 2005 to that in 2007?
Provide a succinct answer. 0.81. What is the ratio of the Aid flow (current US$) of Peru in 2005 to that in 2007?
Your answer should be very brief. 1.65. What is the ratio of the Aid flow (current US$) in OECD members in 2005 to that in 2008?
Your response must be concise. 1.16. What is the ratio of the Aid flow (current US$) of Barbados in 2005 to that in 2008?
Offer a very short reply. 3.74. What is the ratio of the Aid flow (current US$) in Cambodia in 2005 to that in 2008?
Offer a terse response. 1.01. What is the ratio of the Aid flow (current US$) in Peru in 2005 to that in 2008?
Ensure brevity in your answer.  1.65. What is the ratio of the Aid flow (current US$) in OECD members in 2005 to that in 2009?
Offer a terse response. 0.91. What is the ratio of the Aid flow (current US$) in Barbados in 2005 to that in 2009?
Give a very brief answer. 4.42. What is the ratio of the Aid flow (current US$) of Cambodia in 2005 to that in 2009?
Your response must be concise. 1.03. What is the ratio of the Aid flow (current US$) of Peru in 2005 to that in 2009?
Your answer should be compact. 1.49. What is the ratio of the Aid flow (current US$) of OECD members in 2005 to that in 2010?
Offer a very short reply. 0.51. What is the ratio of the Aid flow (current US$) of Barbados in 2005 to that in 2010?
Ensure brevity in your answer.  13.27. What is the ratio of the Aid flow (current US$) in Cambodia in 2005 to that in 2010?
Your answer should be very brief. 0.83. What is the ratio of the Aid flow (current US$) of Peru in 2005 to that in 2010?
Your answer should be compact. 1.19. What is the ratio of the Aid flow (current US$) of OECD members in 2006 to that in 2007?
Your answer should be compact. 1.88. What is the ratio of the Aid flow (current US$) in Barbados in 2006 to that in 2007?
Your response must be concise. 4.49. What is the ratio of the Aid flow (current US$) in Cambodia in 2006 to that in 2007?
Make the answer very short. 0.66. What is the ratio of the Aid flow (current US$) in Peru in 2006 to that in 2007?
Give a very brief answer. 1.99. What is the ratio of the Aid flow (current US$) of OECD members in 2006 to that in 2008?
Your answer should be compact. 1.36. What is the ratio of the Aid flow (current US$) in Barbados in 2006 to that in 2008?
Your answer should be compact. 6.1. What is the ratio of the Aid flow (current US$) of Cambodia in 2006 to that in 2008?
Provide a succinct answer. 0.83. What is the ratio of the Aid flow (current US$) of Peru in 2006 to that in 2008?
Ensure brevity in your answer.  1.99. What is the ratio of the Aid flow (current US$) in OECD members in 2006 to that in 2009?
Your answer should be compact. 1.07. What is the ratio of the Aid flow (current US$) in Barbados in 2006 to that in 2009?
Keep it short and to the point. 7.21. What is the ratio of the Aid flow (current US$) in Cambodia in 2006 to that in 2009?
Your answer should be very brief. 0.84. What is the ratio of the Aid flow (current US$) in Peru in 2006 to that in 2009?
Offer a terse response. 1.79. What is the ratio of the Aid flow (current US$) in OECD members in 2006 to that in 2010?
Give a very brief answer. 0.59. What is the ratio of the Aid flow (current US$) in Barbados in 2006 to that in 2010?
Offer a terse response. 21.64. What is the ratio of the Aid flow (current US$) of Cambodia in 2006 to that in 2010?
Give a very brief answer. 0.68. What is the ratio of the Aid flow (current US$) of Peru in 2006 to that in 2010?
Your answer should be very brief. 1.43. What is the ratio of the Aid flow (current US$) of OECD members in 2007 to that in 2008?
Your answer should be compact. 0.72. What is the ratio of the Aid flow (current US$) in Barbados in 2007 to that in 2008?
Your answer should be compact. 1.36. What is the ratio of the Aid flow (current US$) in Cambodia in 2007 to that in 2008?
Your answer should be very brief. 1.25. What is the ratio of the Aid flow (current US$) in Peru in 2007 to that in 2008?
Offer a terse response. 1. What is the ratio of the Aid flow (current US$) of OECD members in 2007 to that in 2009?
Your answer should be compact. 0.57. What is the ratio of the Aid flow (current US$) of Barbados in 2007 to that in 2009?
Provide a succinct answer. 1.61. What is the ratio of the Aid flow (current US$) in Cambodia in 2007 to that in 2009?
Offer a terse response. 1.27. What is the ratio of the Aid flow (current US$) of Peru in 2007 to that in 2009?
Your answer should be compact. 0.9. What is the ratio of the Aid flow (current US$) in OECD members in 2007 to that in 2010?
Your answer should be very brief. 0.31. What is the ratio of the Aid flow (current US$) in Barbados in 2007 to that in 2010?
Give a very brief answer. 4.82. What is the ratio of the Aid flow (current US$) in Cambodia in 2007 to that in 2010?
Offer a terse response. 1.03. What is the ratio of the Aid flow (current US$) in Peru in 2007 to that in 2010?
Provide a short and direct response. 0.72. What is the ratio of the Aid flow (current US$) in OECD members in 2008 to that in 2009?
Keep it short and to the point. 0.79. What is the ratio of the Aid flow (current US$) in Barbados in 2008 to that in 2009?
Ensure brevity in your answer.  1.18. What is the ratio of the Aid flow (current US$) of Cambodia in 2008 to that in 2009?
Make the answer very short. 1.02. What is the ratio of the Aid flow (current US$) of Peru in 2008 to that in 2009?
Provide a short and direct response. 0.9. What is the ratio of the Aid flow (current US$) in OECD members in 2008 to that in 2010?
Provide a short and direct response. 0.44. What is the ratio of the Aid flow (current US$) of Barbados in 2008 to that in 2010?
Your response must be concise. 3.55. What is the ratio of the Aid flow (current US$) in Cambodia in 2008 to that in 2010?
Keep it short and to the point. 0.82. What is the ratio of the Aid flow (current US$) in Peru in 2008 to that in 2010?
Make the answer very short. 0.72. What is the ratio of the Aid flow (current US$) of OECD members in 2009 to that in 2010?
Ensure brevity in your answer.  0.55. What is the ratio of the Aid flow (current US$) in Barbados in 2009 to that in 2010?
Your response must be concise. 3. What is the ratio of the Aid flow (current US$) in Cambodia in 2009 to that in 2010?
Keep it short and to the point. 0.81. What is the ratio of the Aid flow (current US$) of Peru in 2009 to that in 2010?
Your answer should be very brief. 0.8. What is the difference between the highest and the second highest Aid flow (current US$) of OECD members?
Ensure brevity in your answer.  2.49e+08. What is the difference between the highest and the second highest Aid flow (current US$) of Barbados?
Make the answer very short. 9.20e+05. What is the difference between the highest and the second highest Aid flow (current US$) of Cambodia?
Provide a succinct answer. 2.52e+06. What is the difference between the highest and the second highest Aid flow (current US$) of Peru?
Your answer should be compact. 9.35e+06. What is the difference between the highest and the lowest Aid flow (current US$) of OECD members?
Provide a succinct answer. 4.03e+08. What is the difference between the highest and the lowest Aid flow (current US$) of Barbados?
Make the answer very short. 2.27e+06. What is the difference between the highest and the lowest Aid flow (current US$) of Cambodia?
Offer a very short reply. 3.91e+07. What is the difference between the highest and the lowest Aid flow (current US$) of Peru?
Your answer should be very brief. 9.33e+07. 